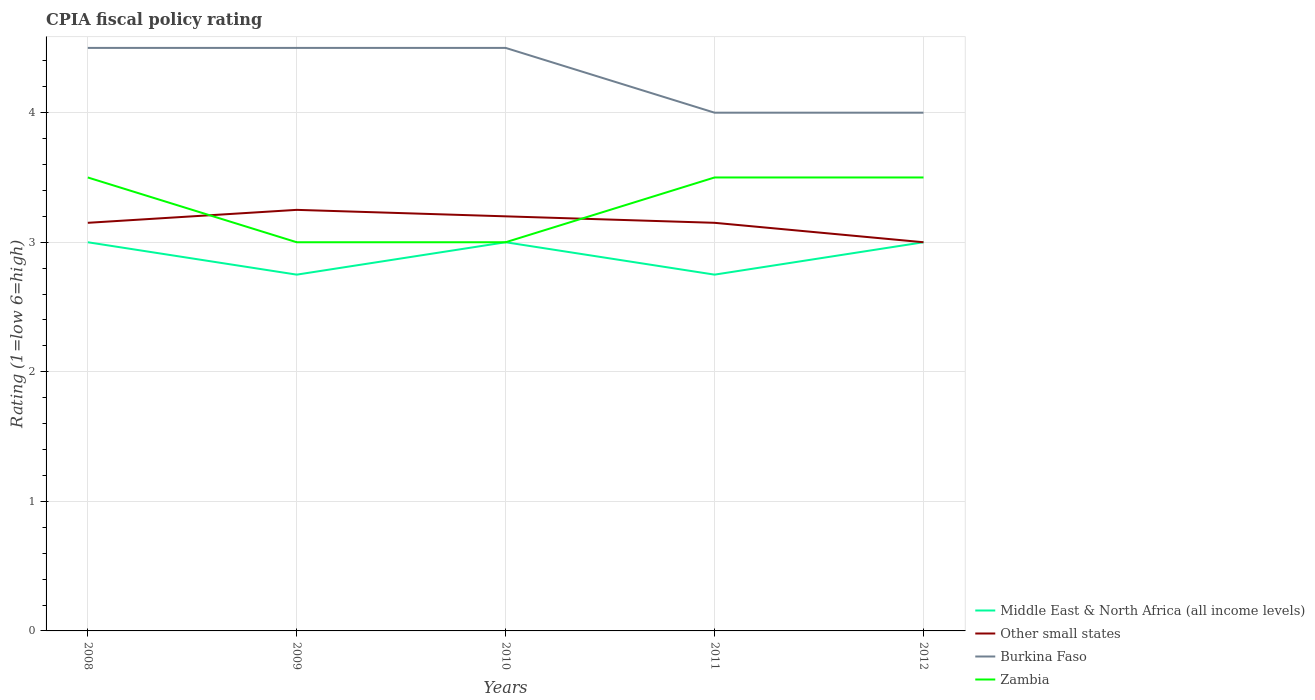How many different coloured lines are there?
Your answer should be very brief. 4. Does the line corresponding to Middle East & North Africa (all income levels) intersect with the line corresponding to Burkina Faso?
Your response must be concise. No. Across all years, what is the maximum CPIA rating in Middle East & North Africa (all income levels)?
Provide a succinct answer. 2.75. What is the total CPIA rating in Middle East & North Africa (all income levels) in the graph?
Offer a terse response. 0. What is the difference between the highest and the lowest CPIA rating in Zambia?
Your answer should be very brief. 3. Is the CPIA rating in Zambia strictly greater than the CPIA rating in Burkina Faso over the years?
Your response must be concise. Yes. How many lines are there?
Your response must be concise. 4. How many years are there in the graph?
Your response must be concise. 5. What is the difference between two consecutive major ticks on the Y-axis?
Provide a succinct answer. 1. Where does the legend appear in the graph?
Provide a succinct answer. Bottom right. What is the title of the graph?
Ensure brevity in your answer.  CPIA fiscal policy rating. What is the label or title of the Y-axis?
Offer a terse response. Rating (1=low 6=high). What is the Rating (1=low 6=high) in Middle East & North Africa (all income levels) in 2008?
Provide a short and direct response. 3. What is the Rating (1=low 6=high) of Other small states in 2008?
Your answer should be very brief. 3.15. What is the Rating (1=low 6=high) in Zambia in 2008?
Offer a terse response. 3.5. What is the Rating (1=low 6=high) of Middle East & North Africa (all income levels) in 2009?
Ensure brevity in your answer.  2.75. What is the Rating (1=low 6=high) of Other small states in 2009?
Ensure brevity in your answer.  3.25. What is the Rating (1=low 6=high) in Burkina Faso in 2009?
Make the answer very short. 4.5. What is the Rating (1=low 6=high) in Zambia in 2009?
Your response must be concise. 3. What is the Rating (1=low 6=high) in Other small states in 2010?
Offer a very short reply. 3.2. What is the Rating (1=low 6=high) in Burkina Faso in 2010?
Your response must be concise. 4.5. What is the Rating (1=low 6=high) in Middle East & North Africa (all income levels) in 2011?
Ensure brevity in your answer.  2.75. What is the Rating (1=low 6=high) in Other small states in 2011?
Make the answer very short. 3.15. What is the Rating (1=low 6=high) of Burkina Faso in 2011?
Offer a terse response. 4. What is the Rating (1=low 6=high) of Zambia in 2011?
Offer a very short reply. 3.5. What is the Rating (1=low 6=high) in Middle East & North Africa (all income levels) in 2012?
Your response must be concise. 3. What is the Rating (1=low 6=high) in Zambia in 2012?
Ensure brevity in your answer.  3.5. Across all years, what is the maximum Rating (1=low 6=high) in Middle East & North Africa (all income levels)?
Your answer should be very brief. 3. Across all years, what is the maximum Rating (1=low 6=high) in Other small states?
Your answer should be very brief. 3.25. Across all years, what is the minimum Rating (1=low 6=high) in Middle East & North Africa (all income levels)?
Make the answer very short. 2.75. What is the total Rating (1=low 6=high) in Middle East & North Africa (all income levels) in the graph?
Keep it short and to the point. 14.5. What is the total Rating (1=low 6=high) of Other small states in the graph?
Provide a succinct answer. 15.75. What is the total Rating (1=low 6=high) in Burkina Faso in the graph?
Offer a terse response. 21.5. What is the total Rating (1=low 6=high) in Zambia in the graph?
Your answer should be very brief. 16.5. What is the difference between the Rating (1=low 6=high) of Other small states in 2008 and that in 2009?
Give a very brief answer. -0.1. What is the difference between the Rating (1=low 6=high) in Burkina Faso in 2008 and that in 2009?
Give a very brief answer. 0. What is the difference between the Rating (1=low 6=high) in Middle East & North Africa (all income levels) in 2008 and that in 2010?
Provide a succinct answer. 0. What is the difference between the Rating (1=low 6=high) of Middle East & North Africa (all income levels) in 2008 and that in 2011?
Ensure brevity in your answer.  0.25. What is the difference between the Rating (1=low 6=high) of Burkina Faso in 2008 and that in 2011?
Provide a short and direct response. 0.5. What is the difference between the Rating (1=low 6=high) in Other small states in 2008 and that in 2012?
Provide a succinct answer. 0.15. What is the difference between the Rating (1=low 6=high) of Burkina Faso in 2008 and that in 2012?
Your answer should be very brief. 0.5. What is the difference between the Rating (1=low 6=high) of Zambia in 2008 and that in 2012?
Provide a succinct answer. 0. What is the difference between the Rating (1=low 6=high) of Burkina Faso in 2009 and that in 2010?
Make the answer very short. 0. What is the difference between the Rating (1=low 6=high) of Zambia in 2009 and that in 2011?
Provide a short and direct response. -0.5. What is the difference between the Rating (1=low 6=high) of Other small states in 2009 and that in 2012?
Provide a short and direct response. 0.25. What is the difference between the Rating (1=low 6=high) of Zambia in 2009 and that in 2012?
Keep it short and to the point. -0.5. What is the difference between the Rating (1=low 6=high) of Burkina Faso in 2010 and that in 2011?
Keep it short and to the point. 0.5. What is the difference between the Rating (1=low 6=high) in Burkina Faso in 2010 and that in 2012?
Keep it short and to the point. 0.5. What is the difference between the Rating (1=low 6=high) in Zambia in 2010 and that in 2012?
Your answer should be very brief. -0.5. What is the difference between the Rating (1=low 6=high) of Middle East & North Africa (all income levels) in 2011 and that in 2012?
Offer a very short reply. -0.25. What is the difference between the Rating (1=low 6=high) of Zambia in 2011 and that in 2012?
Keep it short and to the point. 0. What is the difference between the Rating (1=low 6=high) in Middle East & North Africa (all income levels) in 2008 and the Rating (1=low 6=high) in Other small states in 2009?
Offer a very short reply. -0.25. What is the difference between the Rating (1=low 6=high) in Other small states in 2008 and the Rating (1=low 6=high) in Burkina Faso in 2009?
Offer a terse response. -1.35. What is the difference between the Rating (1=low 6=high) of Middle East & North Africa (all income levels) in 2008 and the Rating (1=low 6=high) of Other small states in 2010?
Offer a terse response. -0.2. What is the difference between the Rating (1=low 6=high) in Middle East & North Africa (all income levels) in 2008 and the Rating (1=low 6=high) in Zambia in 2010?
Your response must be concise. 0. What is the difference between the Rating (1=low 6=high) in Other small states in 2008 and the Rating (1=low 6=high) in Burkina Faso in 2010?
Keep it short and to the point. -1.35. What is the difference between the Rating (1=low 6=high) of Middle East & North Africa (all income levels) in 2008 and the Rating (1=low 6=high) of Other small states in 2011?
Ensure brevity in your answer.  -0.15. What is the difference between the Rating (1=low 6=high) in Middle East & North Africa (all income levels) in 2008 and the Rating (1=low 6=high) in Burkina Faso in 2011?
Offer a very short reply. -1. What is the difference between the Rating (1=low 6=high) in Other small states in 2008 and the Rating (1=low 6=high) in Burkina Faso in 2011?
Ensure brevity in your answer.  -0.85. What is the difference between the Rating (1=low 6=high) in Other small states in 2008 and the Rating (1=low 6=high) in Zambia in 2011?
Your response must be concise. -0.35. What is the difference between the Rating (1=low 6=high) in Middle East & North Africa (all income levels) in 2008 and the Rating (1=low 6=high) in Burkina Faso in 2012?
Make the answer very short. -1. What is the difference between the Rating (1=low 6=high) in Other small states in 2008 and the Rating (1=low 6=high) in Burkina Faso in 2012?
Make the answer very short. -0.85. What is the difference between the Rating (1=low 6=high) of Other small states in 2008 and the Rating (1=low 6=high) of Zambia in 2012?
Provide a succinct answer. -0.35. What is the difference between the Rating (1=low 6=high) in Middle East & North Africa (all income levels) in 2009 and the Rating (1=low 6=high) in Other small states in 2010?
Keep it short and to the point. -0.45. What is the difference between the Rating (1=low 6=high) in Middle East & North Africa (all income levels) in 2009 and the Rating (1=low 6=high) in Burkina Faso in 2010?
Ensure brevity in your answer.  -1.75. What is the difference between the Rating (1=low 6=high) in Other small states in 2009 and the Rating (1=low 6=high) in Burkina Faso in 2010?
Your answer should be very brief. -1.25. What is the difference between the Rating (1=low 6=high) in Other small states in 2009 and the Rating (1=low 6=high) in Zambia in 2010?
Your answer should be compact. 0.25. What is the difference between the Rating (1=low 6=high) in Burkina Faso in 2009 and the Rating (1=low 6=high) in Zambia in 2010?
Offer a very short reply. 1.5. What is the difference between the Rating (1=low 6=high) in Middle East & North Africa (all income levels) in 2009 and the Rating (1=low 6=high) in Burkina Faso in 2011?
Provide a succinct answer. -1.25. What is the difference between the Rating (1=low 6=high) in Middle East & North Africa (all income levels) in 2009 and the Rating (1=low 6=high) in Zambia in 2011?
Provide a succinct answer. -0.75. What is the difference between the Rating (1=low 6=high) in Other small states in 2009 and the Rating (1=low 6=high) in Burkina Faso in 2011?
Your answer should be very brief. -0.75. What is the difference between the Rating (1=low 6=high) of Burkina Faso in 2009 and the Rating (1=low 6=high) of Zambia in 2011?
Offer a very short reply. 1. What is the difference between the Rating (1=low 6=high) in Middle East & North Africa (all income levels) in 2009 and the Rating (1=low 6=high) in Burkina Faso in 2012?
Ensure brevity in your answer.  -1.25. What is the difference between the Rating (1=low 6=high) in Middle East & North Africa (all income levels) in 2009 and the Rating (1=low 6=high) in Zambia in 2012?
Give a very brief answer. -0.75. What is the difference between the Rating (1=low 6=high) of Other small states in 2009 and the Rating (1=low 6=high) of Burkina Faso in 2012?
Offer a very short reply. -0.75. What is the difference between the Rating (1=low 6=high) of Other small states in 2009 and the Rating (1=low 6=high) of Zambia in 2012?
Offer a terse response. -0.25. What is the difference between the Rating (1=low 6=high) of Middle East & North Africa (all income levels) in 2010 and the Rating (1=low 6=high) of Other small states in 2011?
Make the answer very short. -0.15. What is the difference between the Rating (1=low 6=high) of Middle East & North Africa (all income levels) in 2010 and the Rating (1=low 6=high) of Burkina Faso in 2011?
Give a very brief answer. -1. What is the difference between the Rating (1=low 6=high) of Middle East & North Africa (all income levels) in 2010 and the Rating (1=low 6=high) of Zambia in 2011?
Ensure brevity in your answer.  -0.5. What is the difference between the Rating (1=low 6=high) of Other small states in 2010 and the Rating (1=low 6=high) of Burkina Faso in 2012?
Make the answer very short. -0.8. What is the difference between the Rating (1=low 6=high) in Other small states in 2010 and the Rating (1=low 6=high) in Zambia in 2012?
Ensure brevity in your answer.  -0.3. What is the difference between the Rating (1=low 6=high) in Middle East & North Africa (all income levels) in 2011 and the Rating (1=low 6=high) in Other small states in 2012?
Your response must be concise. -0.25. What is the difference between the Rating (1=low 6=high) of Middle East & North Africa (all income levels) in 2011 and the Rating (1=low 6=high) of Burkina Faso in 2012?
Keep it short and to the point. -1.25. What is the difference between the Rating (1=low 6=high) in Middle East & North Africa (all income levels) in 2011 and the Rating (1=low 6=high) in Zambia in 2012?
Provide a succinct answer. -0.75. What is the difference between the Rating (1=low 6=high) of Other small states in 2011 and the Rating (1=low 6=high) of Burkina Faso in 2012?
Provide a short and direct response. -0.85. What is the difference between the Rating (1=low 6=high) of Other small states in 2011 and the Rating (1=low 6=high) of Zambia in 2012?
Provide a succinct answer. -0.35. What is the difference between the Rating (1=low 6=high) in Burkina Faso in 2011 and the Rating (1=low 6=high) in Zambia in 2012?
Keep it short and to the point. 0.5. What is the average Rating (1=low 6=high) in Middle East & North Africa (all income levels) per year?
Your answer should be compact. 2.9. What is the average Rating (1=low 6=high) in Other small states per year?
Ensure brevity in your answer.  3.15. What is the average Rating (1=low 6=high) in Burkina Faso per year?
Make the answer very short. 4.3. What is the average Rating (1=low 6=high) of Zambia per year?
Provide a succinct answer. 3.3. In the year 2008, what is the difference between the Rating (1=low 6=high) in Middle East & North Africa (all income levels) and Rating (1=low 6=high) in Zambia?
Keep it short and to the point. -0.5. In the year 2008, what is the difference between the Rating (1=low 6=high) of Other small states and Rating (1=low 6=high) of Burkina Faso?
Provide a short and direct response. -1.35. In the year 2008, what is the difference between the Rating (1=low 6=high) in Other small states and Rating (1=low 6=high) in Zambia?
Keep it short and to the point. -0.35. In the year 2009, what is the difference between the Rating (1=low 6=high) in Middle East & North Africa (all income levels) and Rating (1=low 6=high) in Burkina Faso?
Provide a short and direct response. -1.75. In the year 2009, what is the difference between the Rating (1=low 6=high) of Other small states and Rating (1=low 6=high) of Burkina Faso?
Provide a short and direct response. -1.25. In the year 2009, what is the difference between the Rating (1=low 6=high) of Other small states and Rating (1=low 6=high) of Zambia?
Offer a very short reply. 0.25. In the year 2010, what is the difference between the Rating (1=low 6=high) of Middle East & North Africa (all income levels) and Rating (1=low 6=high) of Other small states?
Your answer should be very brief. -0.2. In the year 2010, what is the difference between the Rating (1=low 6=high) in Middle East & North Africa (all income levels) and Rating (1=low 6=high) in Burkina Faso?
Ensure brevity in your answer.  -1.5. In the year 2011, what is the difference between the Rating (1=low 6=high) of Middle East & North Africa (all income levels) and Rating (1=low 6=high) of Other small states?
Your response must be concise. -0.4. In the year 2011, what is the difference between the Rating (1=low 6=high) in Middle East & North Africa (all income levels) and Rating (1=low 6=high) in Burkina Faso?
Provide a succinct answer. -1.25. In the year 2011, what is the difference between the Rating (1=low 6=high) of Middle East & North Africa (all income levels) and Rating (1=low 6=high) of Zambia?
Offer a terse response. -0.75. In the year 2011, what is the difference between the Rating (1=low 6=high) of Other small states and Rating (1=low 6=high) of Burkina Faso?
Keep it short and to the point. -0.85. In the year 2011, what is the difference between the Rating (1=low 6=high) of Other small states and Rating (1=low 6=high) of Zambia?
Provide a succinct answer. -0.35. In the year 2011, what is the difference between the Rating (1=low 6=high) in Burkina Faso and Rating (1=low 6=high) in Zambia?
Ensure brevity in your answer.  0.5. In the year 2012, what is the difference between the Rating (1=low 6=high) of Middle East & North Africa (all income levels) and Rating (1=low 6=high) of Zambia?
Your answer should be compact. -0.5. In the year 2012, what is the difference between the Rating (1=low 6=high) in Other small states and Rating (1=low 6=high) in Zambia?
Give a very brief answer. -0.5. In the year 2012, what is the difference between the Rating (1=low 6=high) in Burkina Faso and Rating (1=low 6=high) in Zambia?
Offer a very short reply. 0.5. What is the ratio of the Rating (1=low 6=high) of Middle East & North Africa (all income levels) in 2008 to that in 2009?
Your answer should be compact. 1.09. What is the ratio of the Rating (1=low 6=high) of Other small states in 2008 to that in 2009?
Give a very brief answer. 0.97. What is the ratio of the Rating (1=low 6=high) in Burkina Faso in 2008 to that in 2009?
Your response must be concise. 1. What is the ratio of the Rating (1=low 6=high) in Other small states in 2008 to that in 2010?
Ensure brevity in your answer.  0.98. What is the ratio of the Rating (1=low 6=high) of Zambia in 2008 to that in 2010?
Offer a terse response. 1.17. What is the ratio of the Rating (1=low 6=high) of Middle East & North Africa (all income levels) in 2008 to that in 2011?
Your answer should be very brief. 1.09. What is the ratio of the Rating (1=low 6=high) of Burkina Faso in 2008 to that in 2011?
Your response must be concise. 1.12. What is the ratio of the Rating (1=low 6=high) of Zambia in 2008 to that in 2012?
Offer a terse response. 1. What is the ratio of the Rating (1=low 6=high) of Other small states in 2009 to that in 2010?
Provide a succinct answer. 1.02. What is the ratio of the Rating (1=low 6=high) in Other small states in 2009 to that in 2011?
Your answer should be very brief. 1.03. What is the ratio of the Rating (1=low 6=high) of Burkina Faso in 2009 to that in 2011?
Make the answer very short. 1.12. What is the ratio of the Rating (1=low 6=high) in Zambia in 2009 to that in 2011?
Your response must be concise. 0.86. What is the ratio of the Rating (1=low 6=high) of Middle East & North Africa (all income levels) in 2009 to that in 2012?
Your answer should be compact. 0.92. What is the ratio of the Rating (1=low 6=high) of Other small states in 2009 to that in 2012?
Keep it short and to the point. 1.08. What is the ratio of the Rating (1=low 6=high) of Burkina Faso in 2009 to that in 2012?
Offer a terse response. 1.12. What is the ratio of the Rating (1=low 6=high) in Other small states in 2010 to that in 2011?
Keep it short and to the point. 1.02. What is the ratio of the Rating (1=low 6=high) in Burkina Faso in 2010 to that in 2011?
Provide a succinct answer. 1.12. What is the ratio of the Rating (1=low 6=high) in Middle East & North Africa (all income levels) in 2010 to that in 2012?
Your response must be concise. 1. What is the ratio of the Rating (1=low 6=high) in Other small states in 2010 to that in 2012?
Your answer should be very brief. 1.07. What is the ratio of the Rating (1=low 6=high) in Burkina Faso in 2010 to that in 2012?
Ensure brevity in your answer.  1.12. What is the ratio of the Rating (1=low 6=high) in Zambia in 2011 to that in 2012?
Give a very brief answer. 1. What is the difference between the highest and the second highest Rating (1=low 6=high) of Middle East & North Africa (all income levels)?
Your answer should be compact. 0. What is the difference between the highest and the second highest Rating (1=low 6=high) in Zambia?
Provide a succinct answer. 0. What is the difference between the highest and the lowest Rating (1=low 6=high) of Other small states?
Make the answer very short. 0.25. 